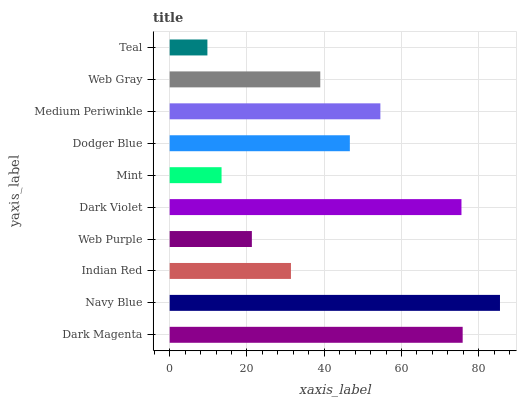Is Teal the minimum?
Answer yes or no. Yes. Is Navy Blue the maximum?
Answer yes or no. Yes. Is Indian Red the minimum?
Answer yes or no. No. Is Indian Red the maximum?
Answer yes or no. No. Is Navy Blue greater than Indian Red?
Answer yes or no. Yes. Is Indian Red less than Navy Blue?
Answer yes or no. Yes. Is Indian Red greater than Navy Blue?
Answer yes or no. No. Is Navy Blue less than Indian Red?
Answer yes or no. No. Is Dodger Blue the high median?
Answer yes or no. Yes. Is Web Gray the low median?
Answer yes or no. Yes. Is Web Gray the high median?
Answer yes or no. No. Is Mint the low median?
Answer yes or no. No. 